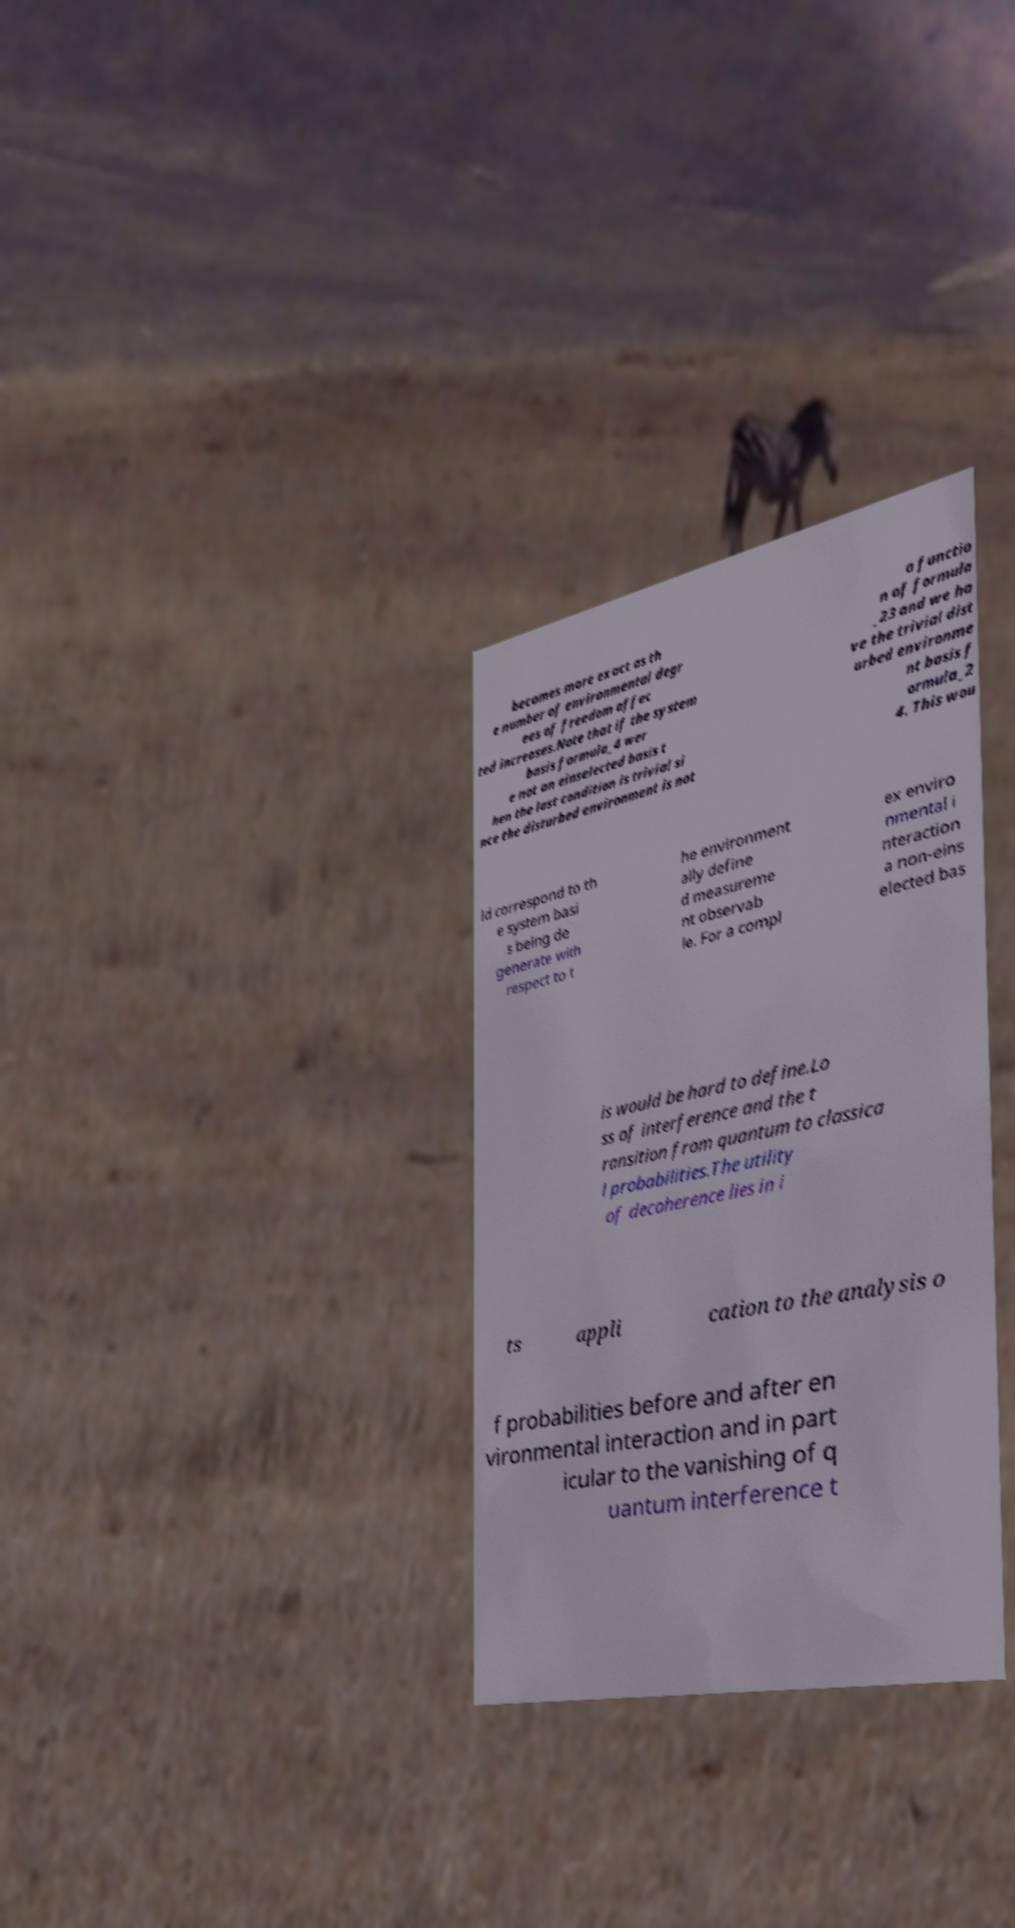There's text embedded in this image that I need extracted. Can you transcribe it verbatim? becomes more exact as th e number of environmental degr ees of freedom affec ted increases.Note that if the system basis formula_4 wer e not an einselected basis t hen the last condition is trivial si nce the disturbed environment is not a functio n of formula _23 and we ha ve the trivial dist urbed environme nt basis f ormula_2 4. This wou ld correspond to th e system basi s being de generate with respect to t he environment ally define d measureme nt observab le. For a compl ex enviro nmental i nteraction a non-eins elected bas is would be hard to define.Lo ss of interference and the t ransition from quantum to classica l probabilities.The utility of decoherence lies in i ts appli cation to the analysis o f probabilities before and after en vironmental interaction and in part icular to the vanishing of q uantum interference t 